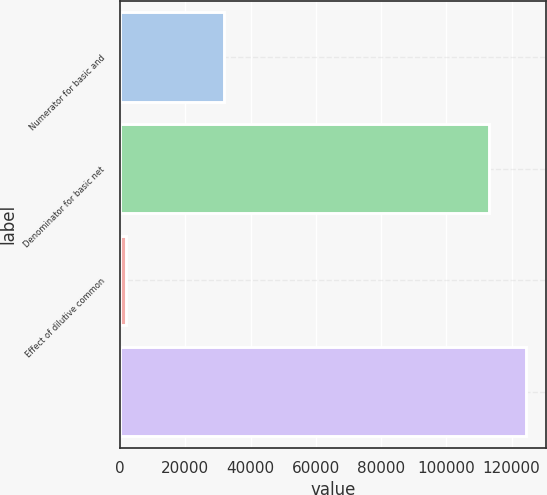Convert chart to OTSL. <chart><loc_0><loc_0><loc_500><loc_500><bar_chart><fcel>Numerator for basic and<fcel>Denominator for basic net<fcel>Effect of dilutive common<fcel>Unnamed: 3<nl><fcel>31904<fcel>113035<fcel>1740<fcel>124338<nl></chart> 